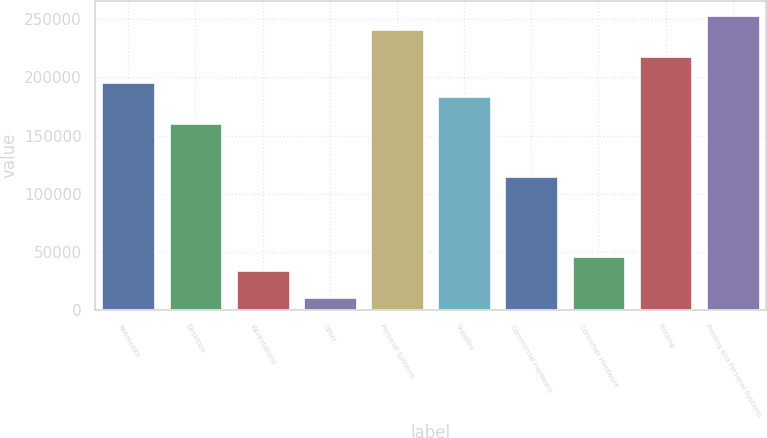<chart> <loc_0><loc_0><loc_500><loc_500><bar_chart><fcel>Notebooks<fcel>Desktops<fcel>Workstations<fcel>Other<fcel>Personal Systems<fcel>Supplies<fcel>Commercial Hardware<fcel>Consumer Hardware<fcel>Printing<fcel>Printing and Personal Systems<nl><fcel>195813<fcel>161262<fcel>34575<fcel>11541<fcel>241881<fcel>184296<fcel>115194<fcel>46092<fcel>218847<fcel>253398<nl></chart> 